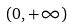<formula> <loc_0><loc_0><loc_500><loc_500>( 0 , + \infty )</formula> 